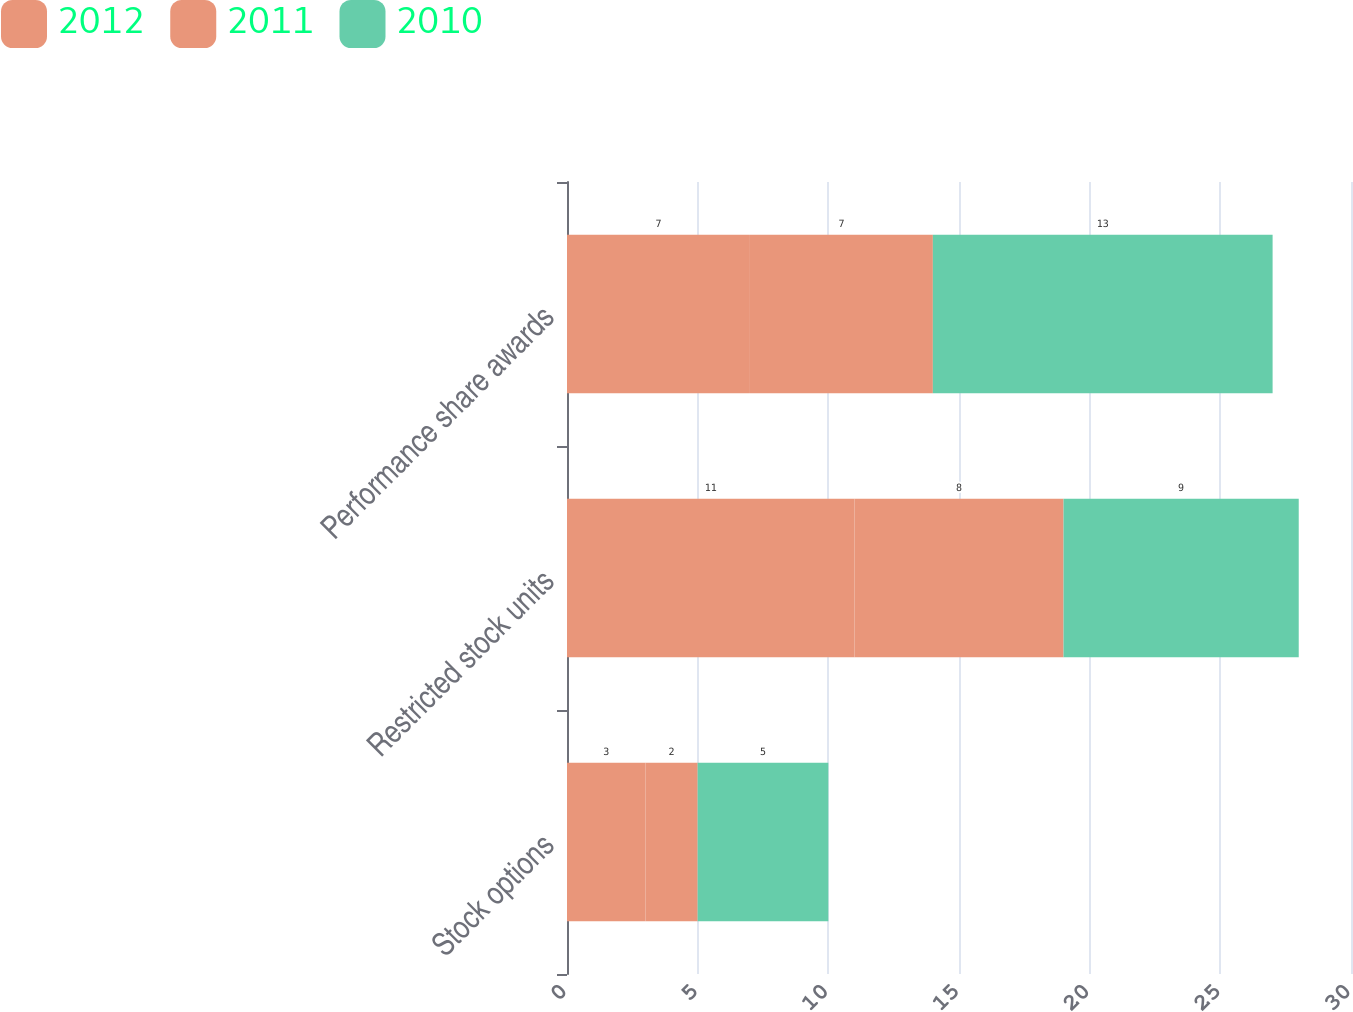<chart> <loc_0><loc_0><loc_500><loc_500><stacked_bar_chart><ecel><fcel>Stock options<fcel>Restricted stock units<fcel>Performance share awards<nl><fcel>2012<fcel>3<fcel>11<fcel>7<nl><fcel>2011<fcel>2<fcel>8<fcel>7<nl><fcel>2010<fcel>5<fcel>9<fcel>13<nl></chart> 